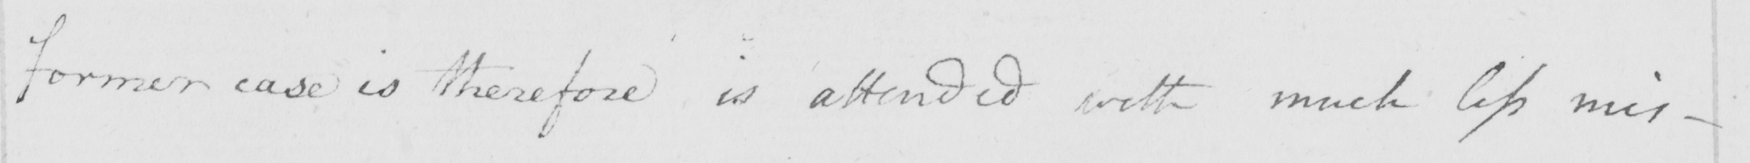Can you read and transcribe this handwriting? former case is therefore is attended with much less mis- 